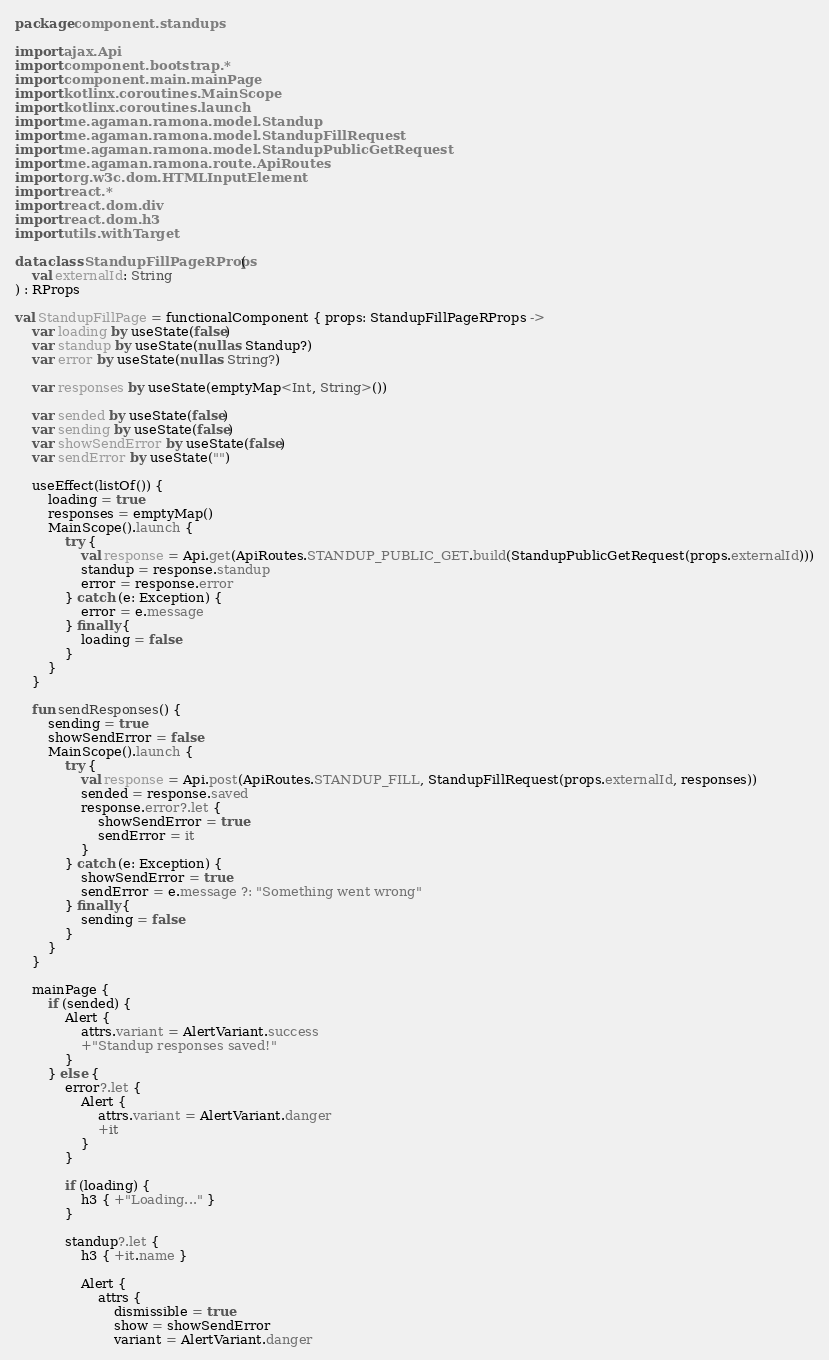Convert code to text. <code><loc_0><loc_0><loc_500><loc_500><_Kotlin_>package component.standups

import ajax.Api
import component.bootstrap.*
import component.main.mainPage
import kotlinx.coroutines.MainScope
import kotlinx.coroutines.launch
import me.agaman.ramona.model.Standup
import me.agaman.ramona.model.StandupFillRequest
import me.agaman.ramona.model.StandupPublicGetRequest
import me.agaman.ramona.route.ApiRoutes
import org.w3c.dom.HTMLInputElement
import react.*
import react.dom.div
import react.dom.h3
import utils.withTarget

data class StandupFillPageRProps(
    val externalId: String
) : RProps

val StandupFillPage = functionalComponent { props: StandupFillPageRProps ->
    var loading by useState(false)
    var standup by useState(null as Standup?)
    var error by useState(null as String?)

    var responses by useState(emptyMap<Int, String>())

    var sended by useState(false)
    var sending by useState(false)
    var showSendError by useState(false)
    var sendError by useState("")

    useEffect(listOf()) {
        loading = true
        responses = emptyMap()
        MainScope().launch {
            try {
                val response = Api.get(ApiRoutes.STANDUP_PUBLIC_GET.build(StandupPublicGetRequest(props.externalId)))
                standup = response.standup
                error = response.error
            } catch (e: Exception) {
                error = e.message
            } finally {
                loading = false
            }
        }
    }

    fun sendResponses() {
        sending = true
        showSendError = false
        MainScope().launch {
            try {
                val response = Api.post(ApiRoutes.STANDUP_FILL, StandupFillRequest(props.externalId, responses))
                sended = response.saved
                response.error?.let {
                    showSendError = true
                    sendError = it
                }
            } catch (e: Exception) {
                showSendError = true
                sendError = e.message ?: "Something went wrong"
            } finally {
                sending = false
            }
        }
    }

    mainPage {
        if (sended) {
            Alert {
                attrs.variant = AlertVariant.success
                +"Standup responses saved!"
            }
        } else {
            error?.let {
                Alert {
                    attrs.variant = AlertVariant.danger
                    +it
                }
            }

            if (loading) {
                h3 { +"Loading..." }
            }

            standup?.let {
                h3 { +it.name }

                Alert {
                    attrs {
                        dismissible = true
                        show = showSendError
                        variant = AlertVariant.danger</code> 